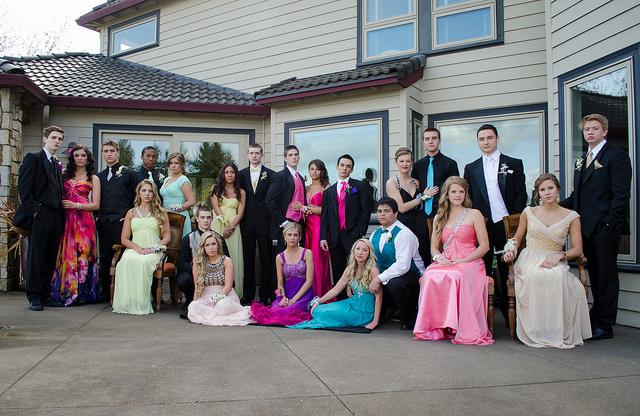Why is everyone posed so ornately? prom 